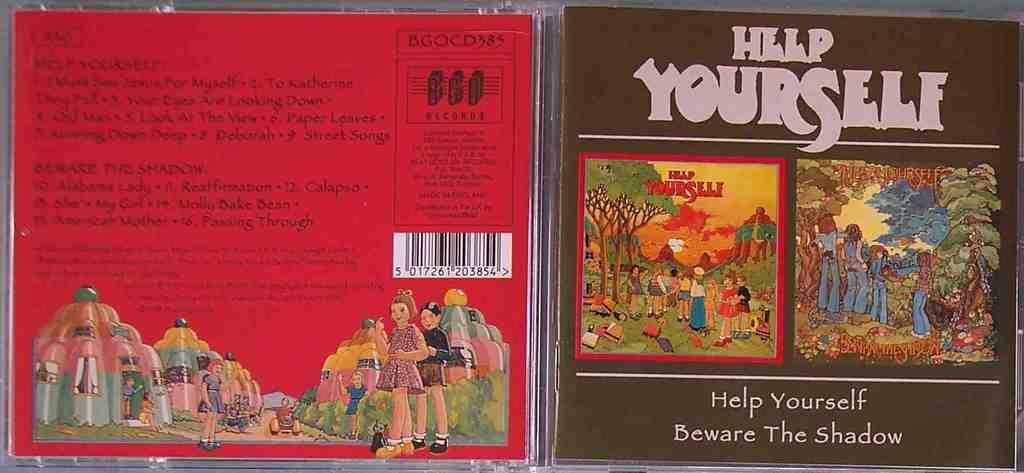What does it say to beware of?
Ensure brevity in your answer.  The shadow. What does the first page of the right say>?
Give a very brief answer. Help yourself. 